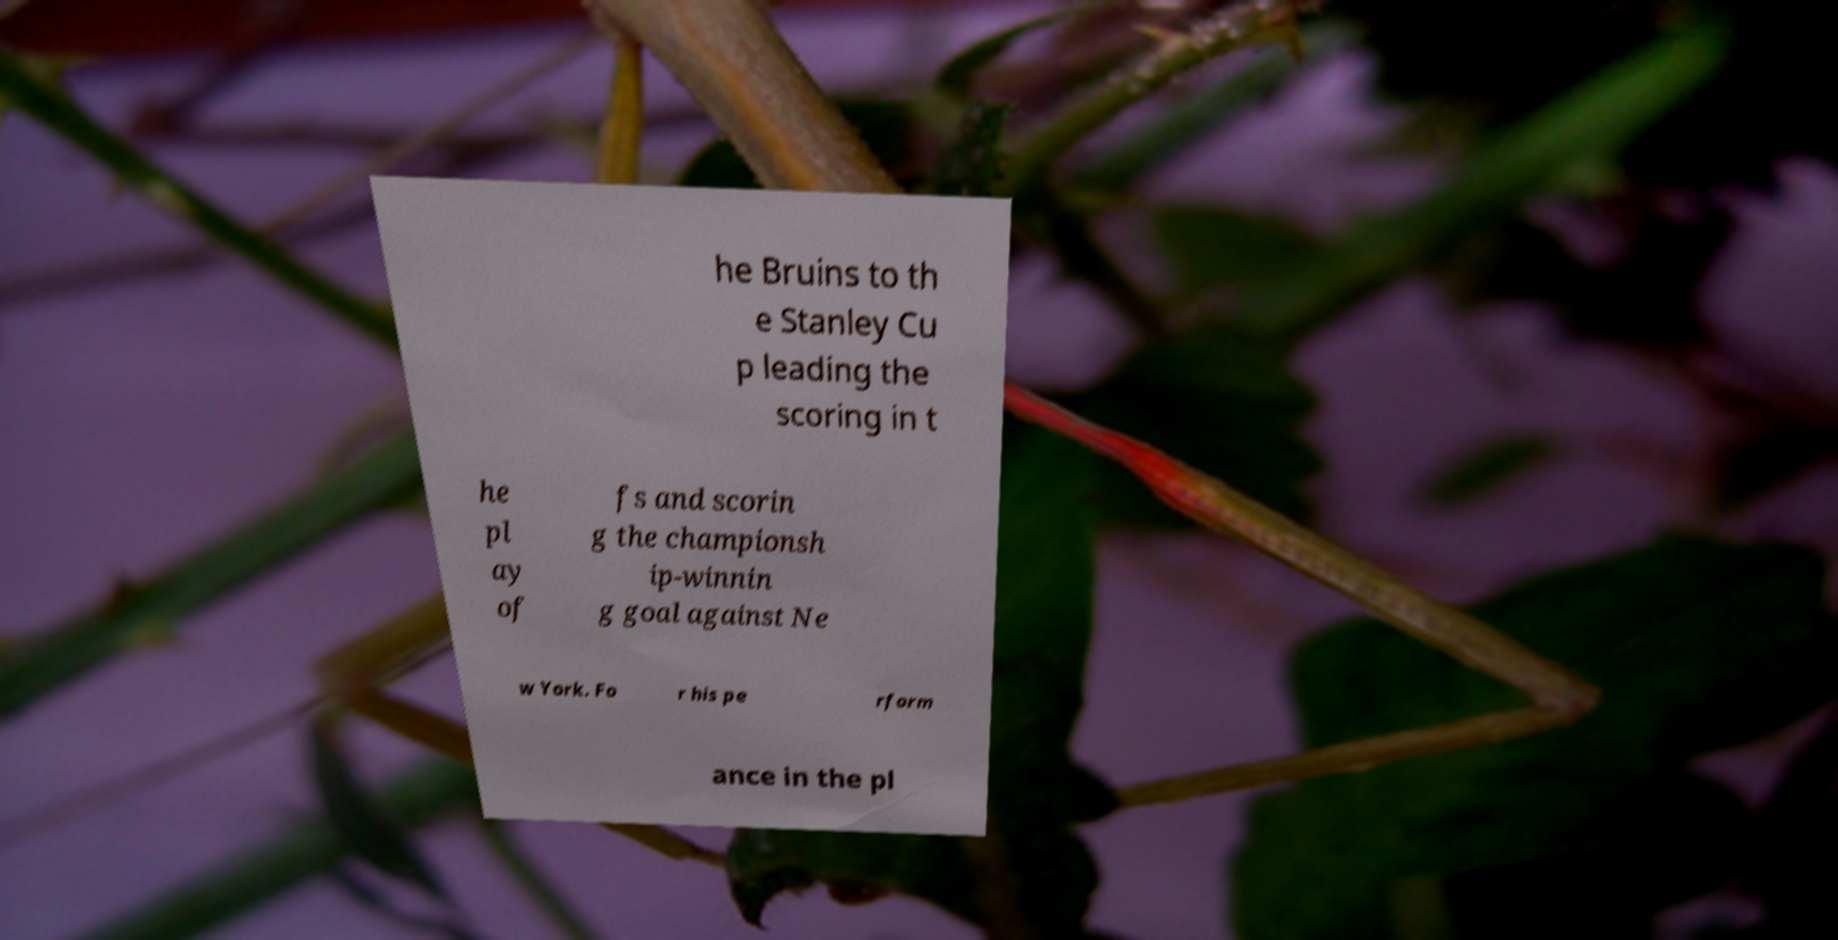Could you extract and type out the text from this image? he Bruins to th e Stanley Cu p leading the scoring in t he pl ay of fs and scorin g the championsh ip-winnin g goal against Ne w York. Fo r his pe rform ance in the pl 